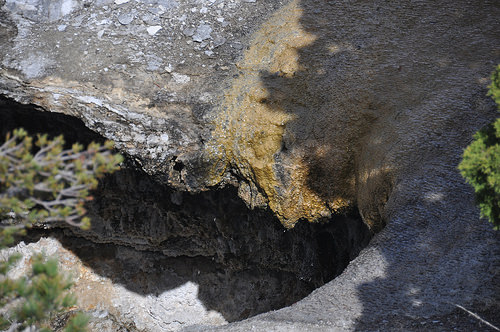<image>
Is the tree above the hole? Yes. The tree is positioned above the hole in the vertical space, higher up in the scene. 